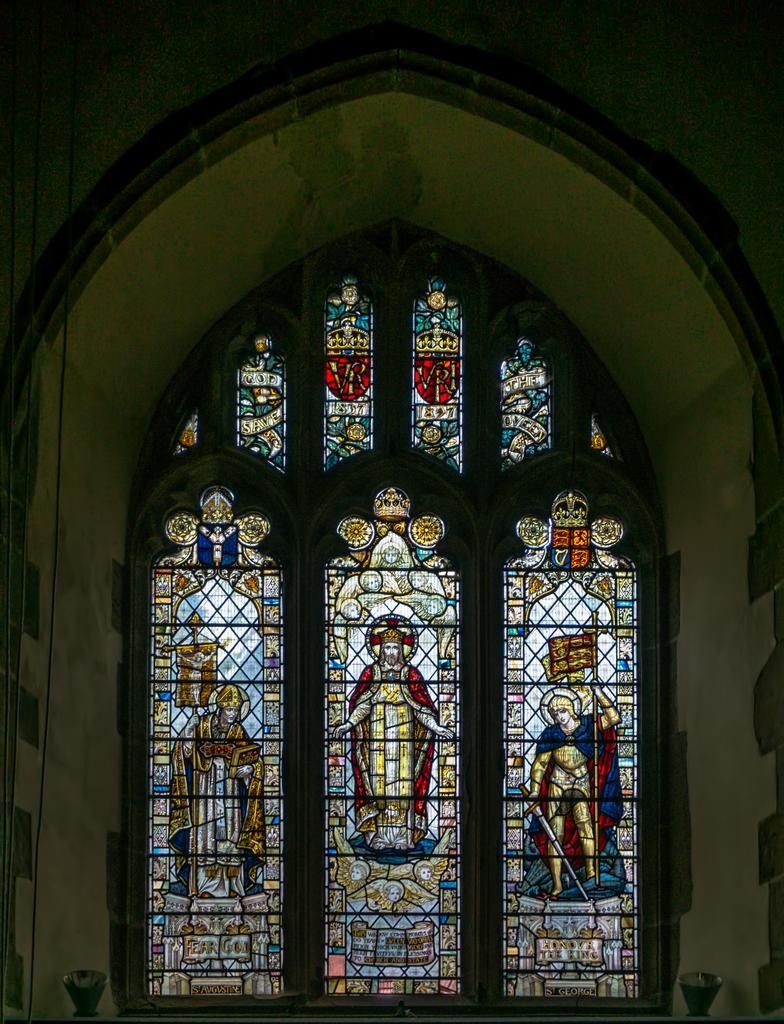Where was the image taken? The image was taken inside a building. What can be seen on the glasses in the image? There are paintings on the glasses. Can you describe the object at the bottom of the image? Unfortunately, the facts provided do not give enough information to describe the object at the bottom of the image. What type of bears can be seen playing with a plastic wave in the image? There are no bears or plastic waves present in the image. 